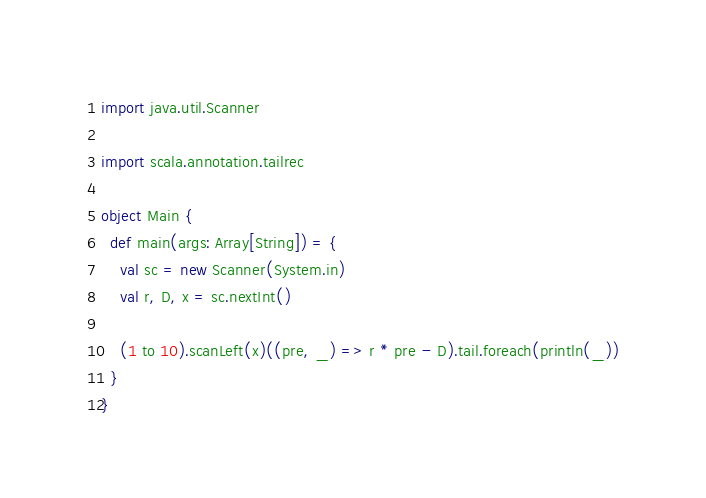<code> <loc_0><loc_0><loc_500><loc_500><_Scala_>import java.util.Scanner

import scala.annotation.tailrec

object Main {
  def main(args: Array[String]) = {
    val sc = new Scanner(System.in)
    val r, D, x = sc.nextInt()

    (1 to 10).scanLeft(x)((pre, _) => r * pre - D).tail.foreach(println(_))
  }
}</code> 